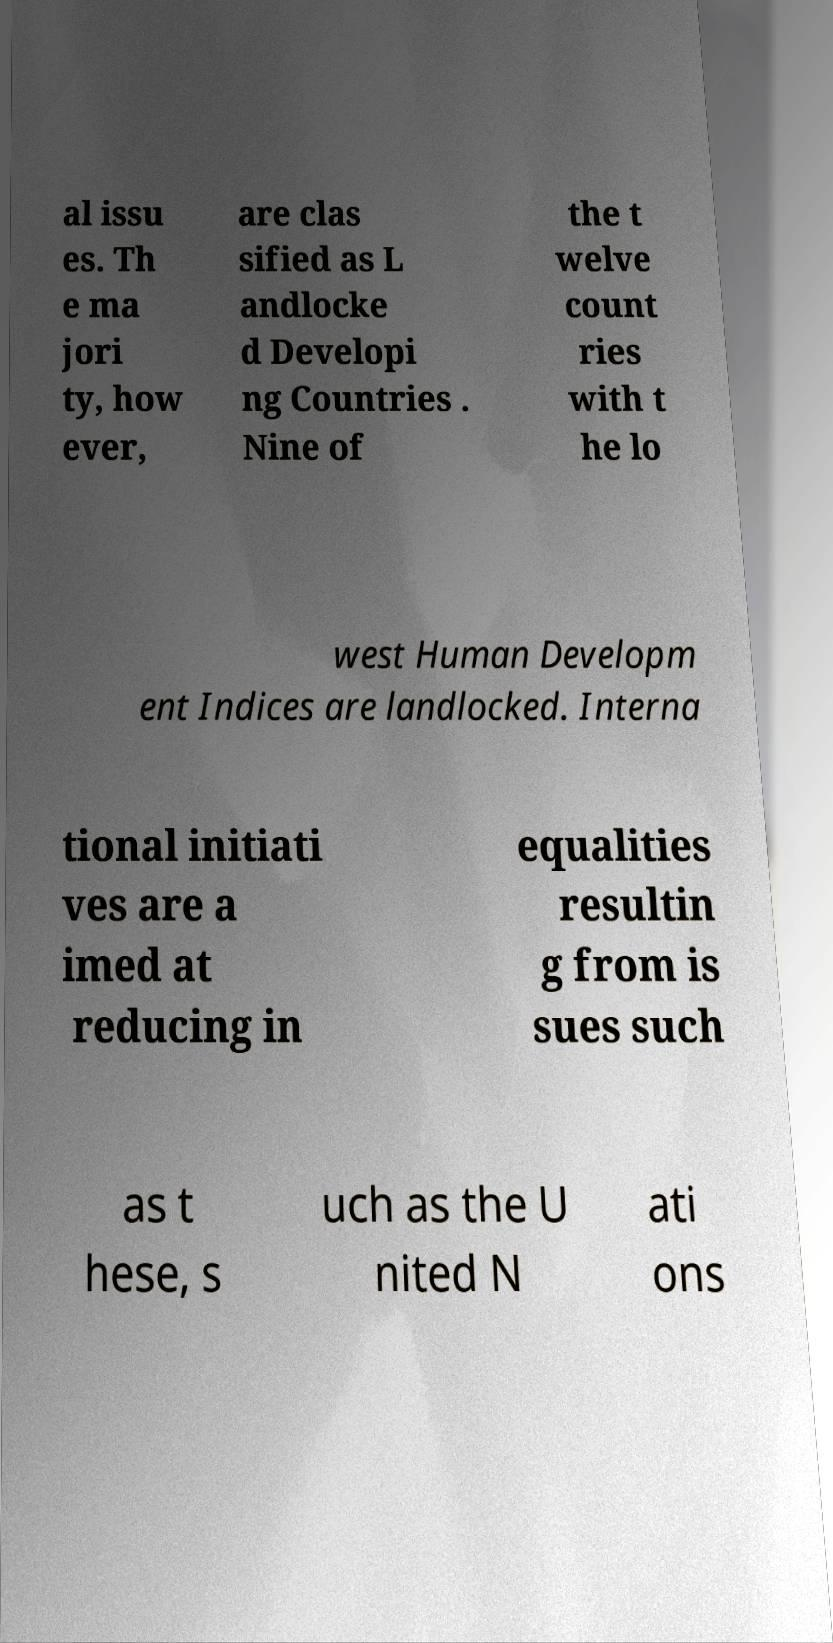For documentation purposes, I need the text within this image transcribed. Could you provide that? al issu es. Th e ma jori ty, how ever, are clas sified as L andlocke d Developi ng Countries . Nine of the t welve count ries with t he lo west Human Developm ent Indices are landlocked. Interna tional initiati ves are a imed at reducing in equalities resultin g from is sues such as t hese, s uch as the U nited N ati ons 